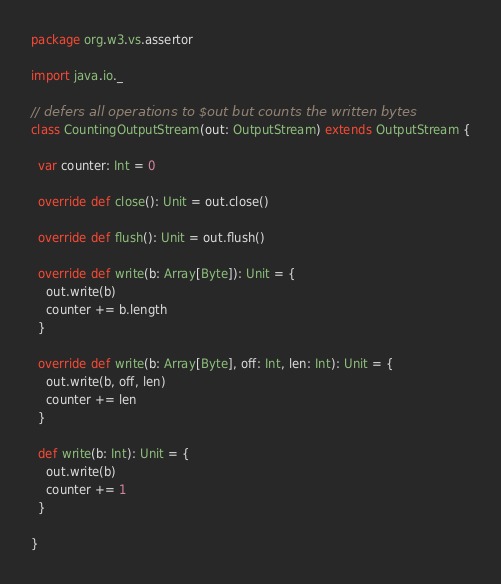Convert code to text. <code><loc_0><loc_0><loc_500><loc_500><_Scala_>package org.w3.vs.assertor

import java.io._

// defers all operations to $out but counts the written bytes
class CountingOutputStream(out: OutputStream) extends OutputStream {

  var counter: Int = 0

  override def close(): Unit = out.close()

  override def flush(): Unit = out.flush()

  override def write(b: Array[Byte]): Unit = {
    out.write(b)
    counter += b.length
  }

  override def write(b: Array[Byte], off: Int, len: Int): Unit = {
    out.write(b, off, len)
    counter += len
  }

  def write(b: Int): Unit = {
    out.write(b)
    counter += 1
  }

}
</code> 